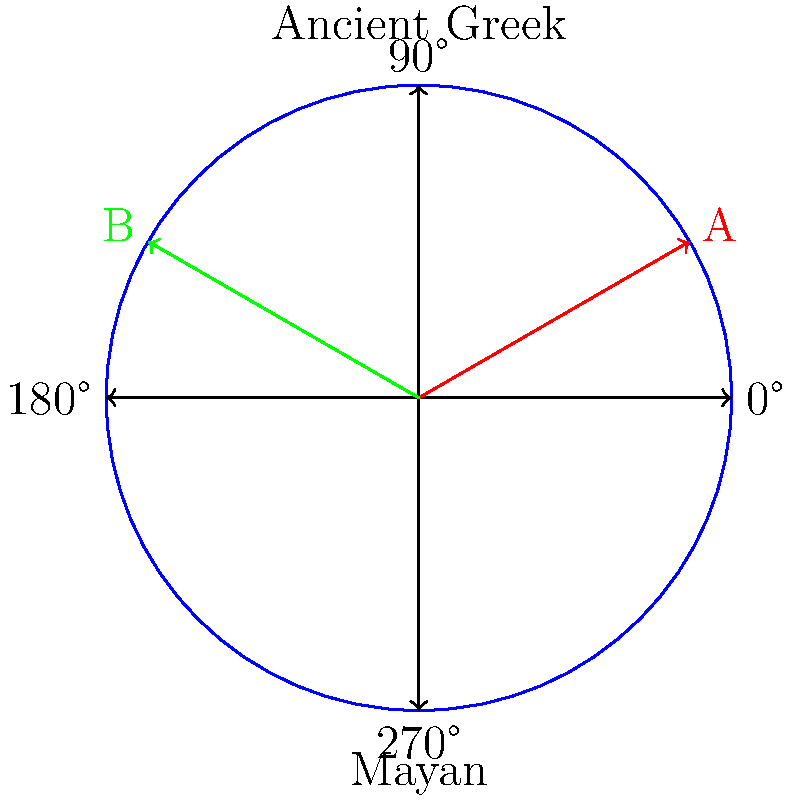In the diagram, point A represents the position of a celestial body in Ancient Greek astronomy, while point B represents the same body's position in Mayan astronomy. If we consider the Ancient Greek system as the reference frame, what transformation would be required to align the Mayan observation (point B) with the Greek observation (point A)? To solve this problem, we need to follow these steps:

1. Identify the angles of points A and B:
   Point A is at 30° (Ancient Greek observation)
   Point B is at 150° (Mayan observation)

2. Calculate the angle between A and B:
   $150° - 30° = 120°$

3. Determine the direction of rotation:
   To move from B to A, we need to rotate clockwise.

4. In mathematical terms, a clockwise rotation is represented by a negative angle.

5. Therefore, the required transformation is a rotation of -120° (or 240° counterclockwise) around the origin.

This problem highlights how different cultural astronomies might have observed and recorded celestial phenomena differently, despite observing the same physical reality. The transformation required to align these observations demonstrates the mathematical relationship between these different cultural perspectives.
Answer: Rotation by -120° (or 240° counterclockwise) 